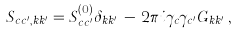<formula> <loc_0><loc_0><loc_500><loc_500>S _ { c c ^ { \prime } , k k ^ { \prime } } = S ^ { ( 0 ) } _ { c c ^ { \prime } } \delta _ { k k ^ { \prime } } \, - \, 2 \pi i \gamma _ { c } \gamma _ { c ^ { \prime } } G _ { k k ^ { \prime } } \, ,</formula> 